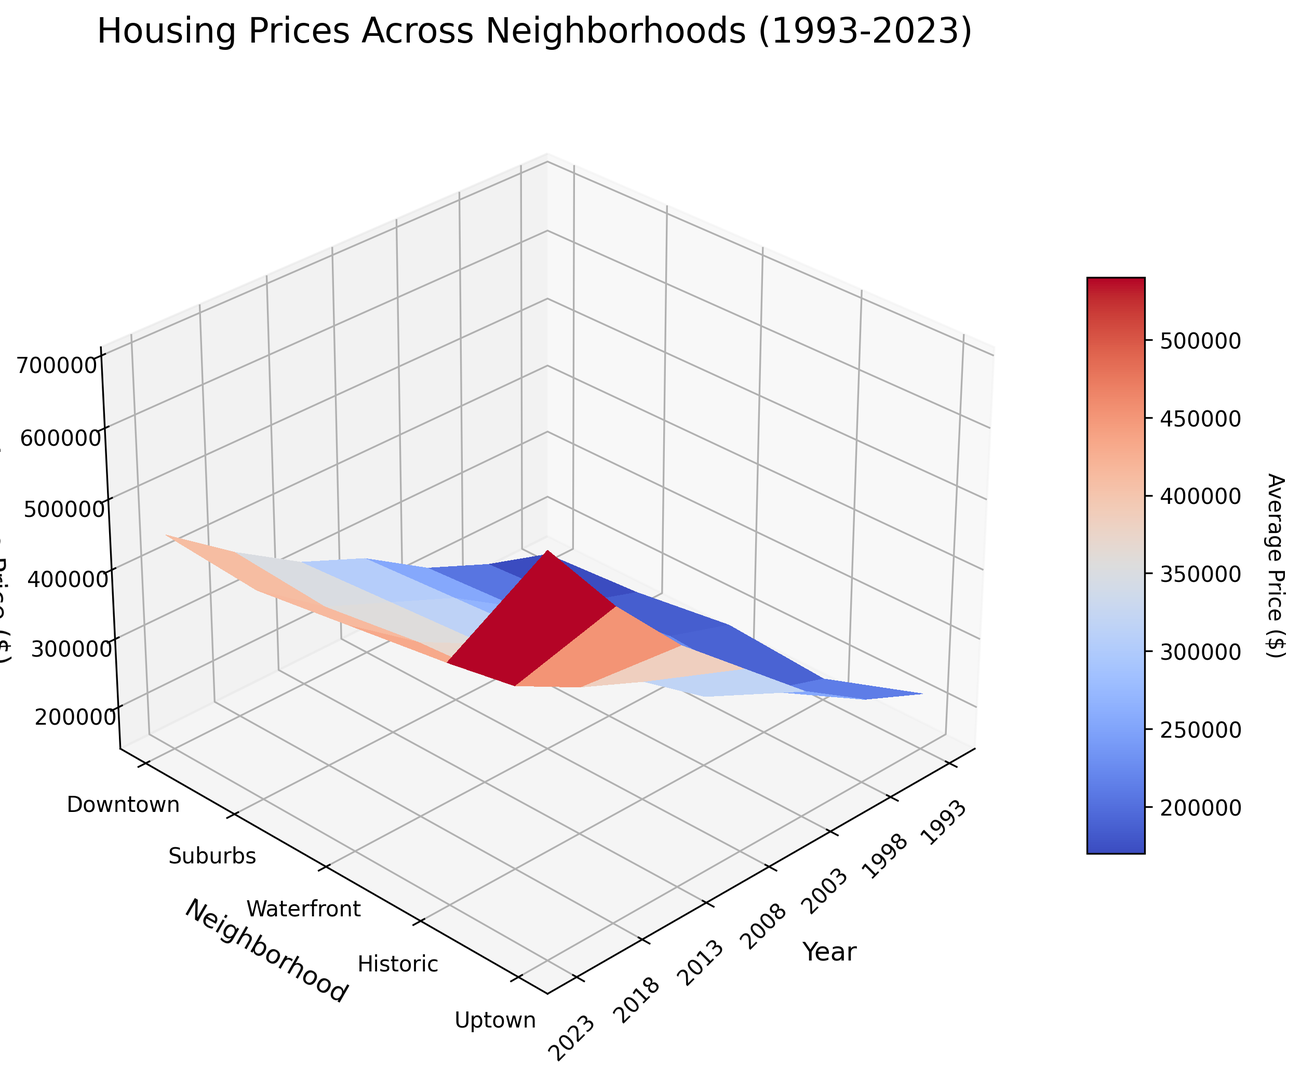What is the overall trend in housing prices for the Waterfront neighborhood over the 30-year period? To answer this, look at the surface plot specifically for the Waterfront neighborhood over the years. The graph shows that the Waterfront neighborhood has a consistently increasing trend. Starting from 220,000 USD in 1993, the price peaks at 700,000 USD in 2023.
Answer: The prices are steadily increasing Which neighborhood had the highest average price in 2023? To determine this, locate the year 2023 on the x-axis and identify the tallest peak in that column. The Waterfront neighborhood has the highest price in 2023 compared to other neighborhoods.
Answer: Waterfront By how much did the average price for the Downtown neighborhood increase from 1993 to 2023? Compare the heights of the surfaces for the Downtown neighborhood in 1993 and 2023. The Downtown neighborhood's height increased from 150,000 USD in 1993 to 450,000 USD in 2023. The difference is 450,000 - 150,000 = 300,000 USD.
Answer: 300,000 USD Which neighborhood shows the most stability in price changes over the years? To determine stability, look for the neighborhood with the least variation in surface height over the years. The Historic neighborhood shows relatively minor fluctuations compared to others, indicating stability in prices.
Answer: Historic In which year did Uptown see the most significant price increase compared to the previous period? Observe the changes in height along the Uptown row across different years. The most significant increase is between 2008 (310,000 USD) and 2013 (350,000 USD), which is an increase of 40,000 USD.
Answer: 2013 How does the price trend for Suburbs compare to Downtown? Analyzing the surface plots of both neighborhoods reveals that while both show a general increasing trend, the Downtown prices rise more steeply than those in the Suburbs, especially noticeable post-2008.
Answer: Downtown prices increase more steeply What is the price difference between the most expensive and least expensive neighborhoods in 2018? Identify the tallest and shortest surface points for the year 2018. Waterfront is the most expensive at 580,000 USD and Downtown is the least expensive at 380,000 USD. The difference is 580,000 - 380,000 = 200,000 USD.
Answer: 200,000 USD In which period did the Waterfront neighborhood experience the highest growth rate in average price? Look for the largest change in surface height between consecutive years in the Waterfront row. The highest growth rate occurred between 2013 (480,000 USD) and 2018 (580,000 USD), an increase of 100,000 USD.
Answer: 2013-2018 